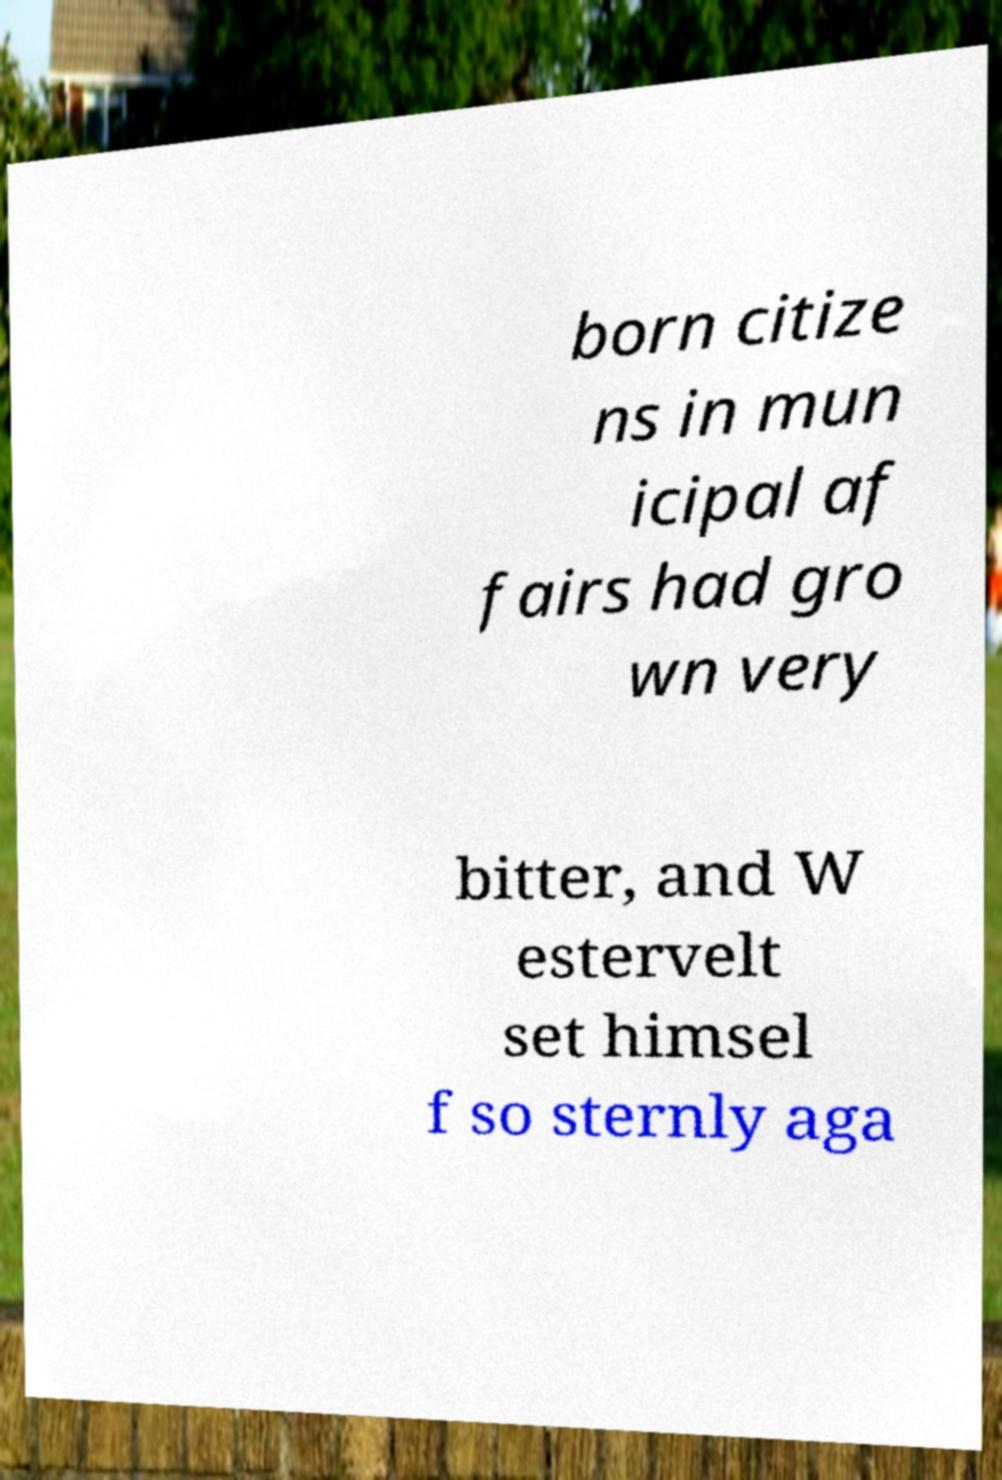Please read and relay the text visible in this image. What does it say? born citize ns in mun icipal af fairs had gro wn very bitter, and W estervelt set himsel f so sternly aga 